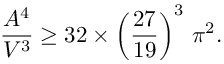<formula> <loc_0><loc_0><loc_500><loc_500>\frac { A ^ { 4 } } { V ^ { 3 } } \geq 3 2 \times \left ( \frac { 2 7 } { 1 9 } \right ) ^ { 3 } \, \pi ^ { 2 } .</formula> 